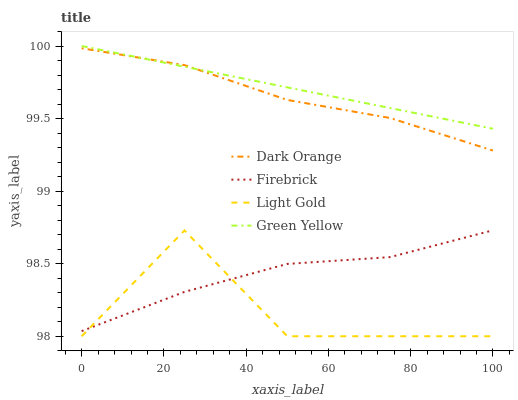Does Light Gold have the minimum area under the curve?
Answer yes or no. Yes. Does Green Yellow have the maximum area under the curve?
Answer yes or no. Yes. Does Firebrick have the minimum area under the curve?
Answer yes or no. No. Does Firebrick have the maximum area under the curve?
Answer yes or no. No. Is Green Yellow the smoothest?
Answer yes or no. Yes. Is Light Gold the roughest?
Answer yes or no. Yes. Is Firebrick the smoothest?
Answer yes or no. No. Is Firebrick the roughest?
Answer yes or no. No. Does Light Gold have the lowest value?
Answer yes or no. Yes. Does Firebrick have the lowest value?
Answer yes or no. No. Does Green Yellow have the highest value?
Answer yes or no. Yes. Does Firebrick have the highest value?
Answer yes or no. No. Is Light Gold less than Green Yellow?
Answer yes or no. Yes. Is Dark Orange greater than Light Gold?
Answer yes or no. Yes. Does Dark Orange intersect Green Yellow?
Answer yes or no. Yes. Is Dark Orange less than Green Yellow?
Answer yes or no. No. Is Dark Orange greater than Green Yellow?
Answer yes or no. No. Does Light Gold intersect Green Yellow?
Answer yes or no. No. 